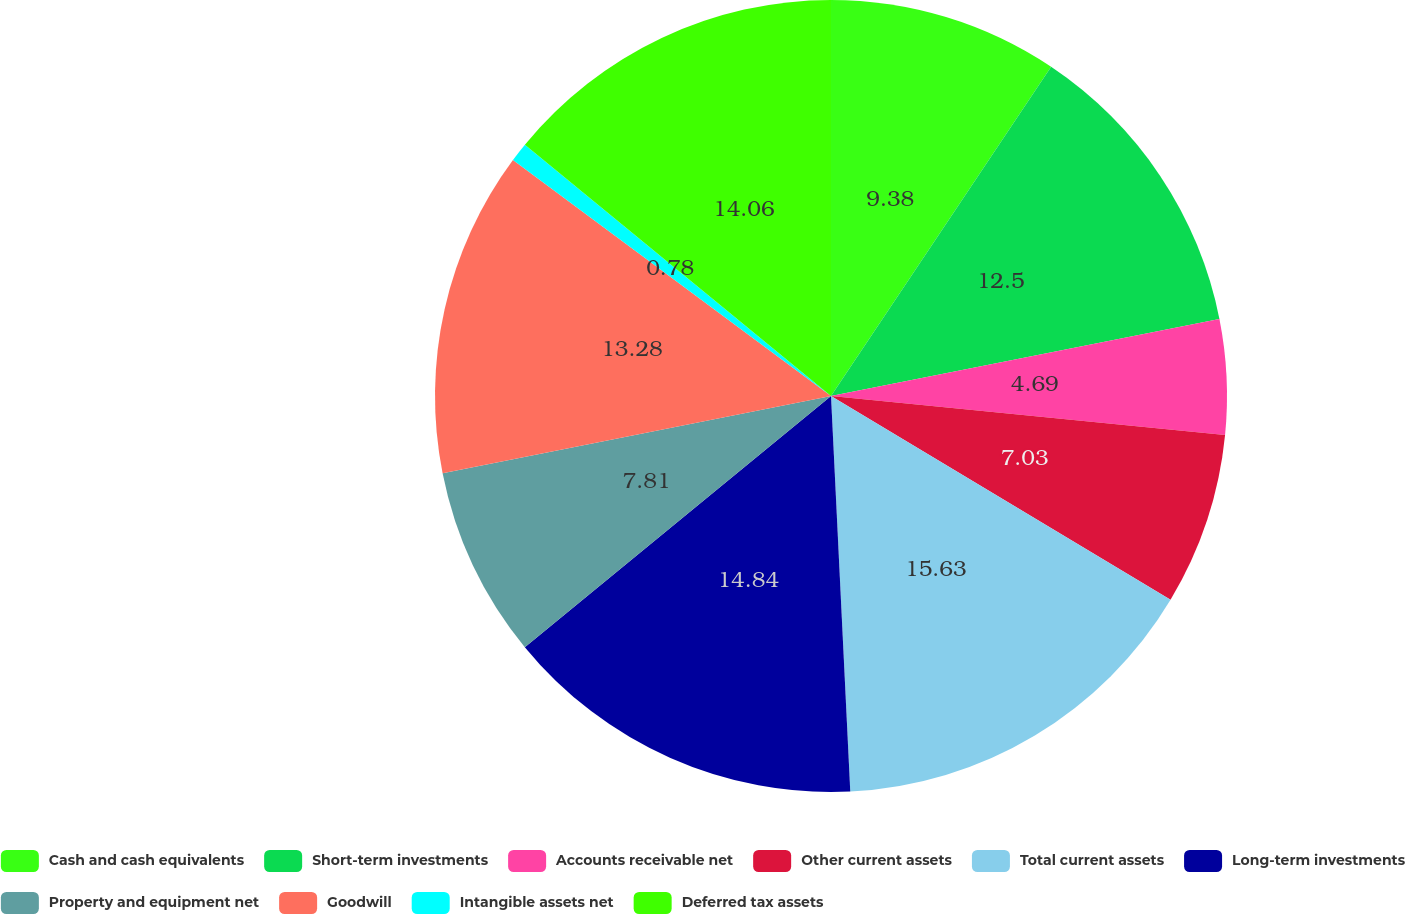<chart> <loc_0><loc_0><loc_500><loc_500><pie_chart><fcel>Cash and cash equivalents<fcel>Short-term investments<fcel>Accounts receivable net<fcel>Other current assets<fcel>Total current assets<fcel>Long-term investments<fcel>Property and equipment net<fcel>Goodwill<fcel>Intangible assets net<fcel>Deferred tax assets<nl><fcel>9.38%<fcel>12.5%<fcel>4.69%<fcel>7.03%<fcel>15.62%<fcel>14.84%<fcel>7.81%<fcel>13.28%<fcel>0.78%<fcel>14.06%<nl></chart> 